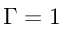<formula> <loc_0><loc_0><loc_500><loc_500>\Gamma = 1</formula> 